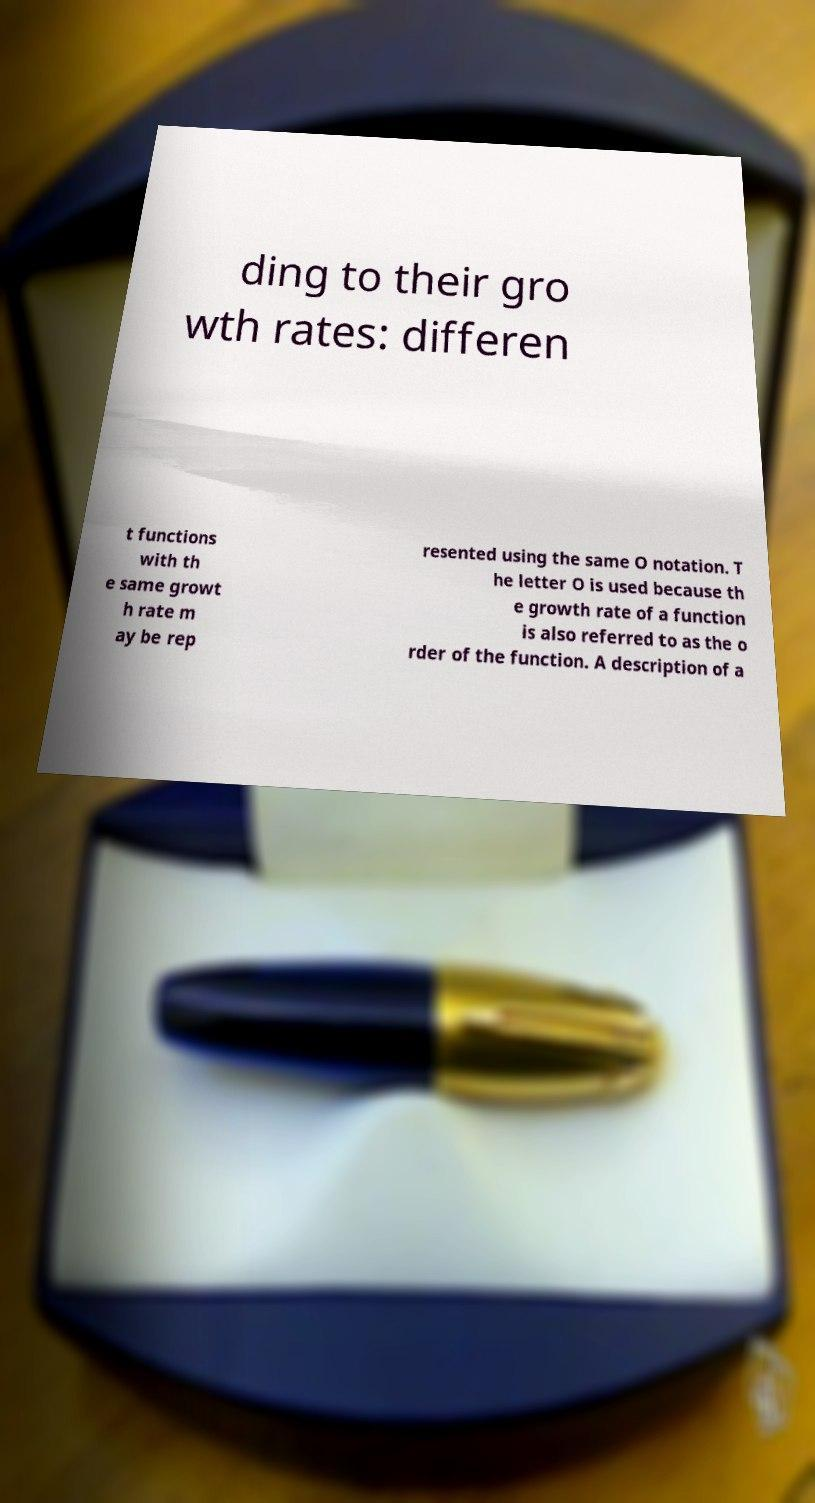Can you accurately transcribe the text from the provided image for me? ding to their gro wth rates: differen t functions with th e same growt h rate m ay be rep resented using the same O notation. T he letter O is used because th e growth rate of a function is also referred to as the o rder of the function. A description of a 